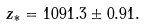<formula> <loc_0><loc_0><loc_500><loc_500>z _ { * } = 1 0 9 1 . 3 \pm 0 . 9 1 .</formula> 